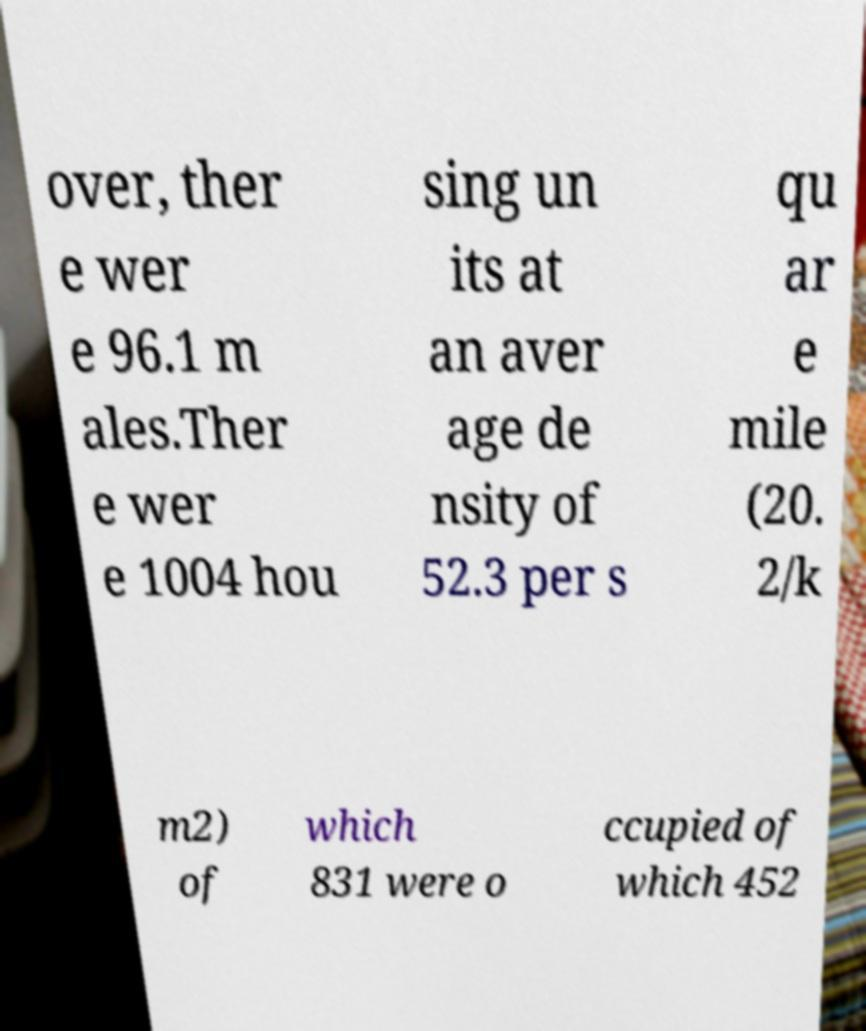What messages or text are displayed in this image? I need them in a readable, typed format. over, ther e wer e 96.1 m ales.Ther e wer e 1004 hou sing un its at an aver age de nsity of 52.3 per s qu ar e mile (20. 2/k m2) of which 831 were o ccupied of which 452 